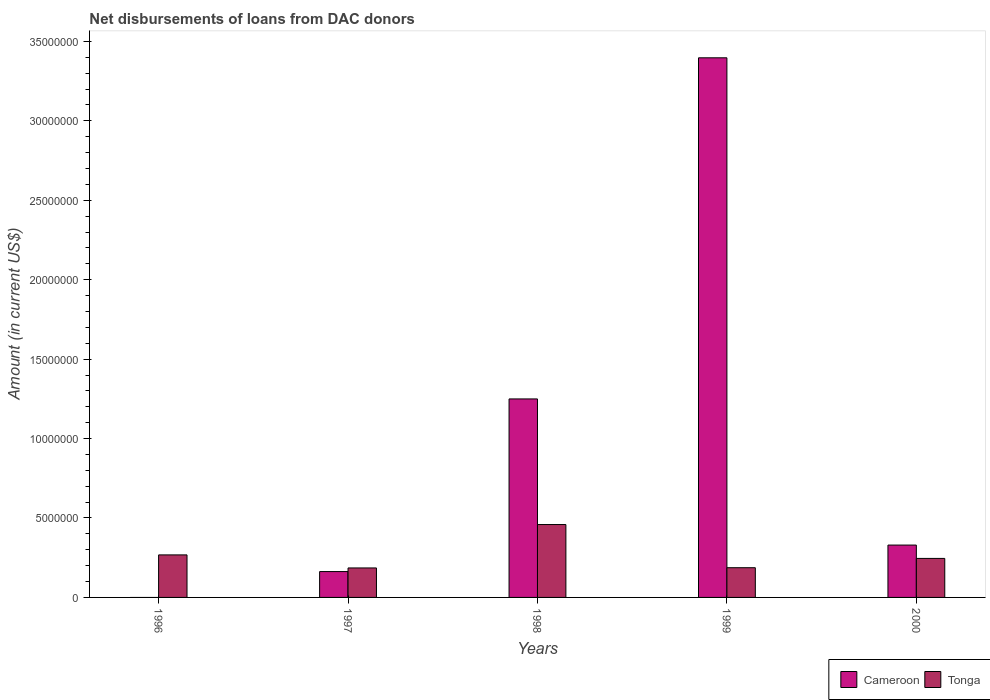How many different coloured bars are there?
Your response must be concise. 2. How many bars are there on the 5th tick from the left?
Offer a terse response. 2. How many bars are there on the 3rd tick from the right?
Your answer should be very brief. 2. What is the amount of loans disbursed in Cameroon in 1998?
Keep it short and to the point. 1.25e+07. Across all years, what is the maximum amount of loans disbursed in Tonga?
Ensure brevity in your answer.  4.59e+06. Across all years, what is the minimum amount of loans disbursed in Cameroon?
Offer a terse response. 0. In which year was the amount of loans disbursed in Tonga maximum?
Give a very brief answer. 1998. What is the total amount of loans disbursed in Tonga in the graph?
Ensure brevity in your answer.  1.34e+07. What is the difference between the amount of loans disbursed in Cameroon in 1999 and that in 2000?
Your answer should be compact. 3.07e+07. What is the difference between the amount of loans disbursed in Tonga in 1997 and the amount of loans disbursed in Cameroon in 1996?
Keep it short and to the point. 1.86e+06. What is the average amount of loans disbursed in Cameroon per year?
Provide a succinct answer. 1.03e+07. In the year 1999, what is the difference between the amount of loans disbursed in Tonga and amount of loans disbursed in Cameroon?
Provide a short and direct response. -3.21e+07. In how many years, is the amount of loans disbursed in Cameroon greater than 28000000 US$?
Provide a succinct answer. 1. What is the ratio of the amount of loans disbursed in Tonga in 1996 to that in 1999?
Provide a short and direct response. 1.43. Is the amount of loans disbursed in Tonga in 1996 less than that in 1998?
Give a very brief answer. Yes. Is the difference between the amount of loans disbursed in Tonga in 1997 and 1999 greater than the difference between the amount of loans disbursed in Cameroon in 1997 and 1999?
Your answer should be compact. Yes. What is the difference between the highest and the second highest amount of loans disbursed in Cameroon?
Your answer should be compact. 2.15e+07. What is the difference between the highest and the lowest amount of loans disbursed in Tonga?
Give a very brief answer. 2.73e+06. How many bars are there?
Offer a very short reply. 9. Are all the bars in the graph horizontal?
Ensure brevity in your answer.  No. What is the difference between two consecutive major ticks on the Y-axis?
Keep it short and to the point. 5.00e+06. How are the legend labels stacked?
Your answer should be compact. Horizontal. What is the title of the graph?
Keep it short and to the point. Net disbursements of loans from DAC donors. Does "Jordan" appear as one of the legend labels in the graph?
Give a very brief answer. No. What is the label or title of the X-axis?
Make the answer very short. Years. What is the label or title of the Y-axis?
Provide a short and direct response. Amount (in current US$). What is the Amount (in current US$) in Cameroon in 1996?
Provide a short and direct response. 0. What is the Amount (in current US$) of Tonga in 1996?
Your response must be concise. 2.68e+06. What is the Amount (in current US$) of Cameroon in 1997?
Offer a terse response. 1.63e+06. What is the Amount (in current US$) in Tonga in 1997?
Offer a very short reply. 1.86e+06. What is the Amount (in current US$) in Cameroon in 1998?
Keep it short and to the point. 1.25e+07. What is the Amount (in current US$) of Tonga in 1998?
Provide a short and direct response. 4.59e+06. What is the Amount (in current US$) in Cameroon in 1999?
Keep it short and to the point. 3.40e+07. What is the Amount (in current US$) of Tonga in 1999?
Offer a very short reply. 1.87e+06. What is the Amount (in current US$) in Cameroon in 2000?
Give a very brief answer. 3.30e+06. What is the Amount (in current US$) of Tonga in 2000?
Your answer should be compact. 2.46e+06. Across all years, what is the maximum Amount (in current US$) in Cameroon?
Your answer should be very brief. 3.40e+07. Across all years, what is the maximum Amount (in current US$) of Tonga?
Give a very brief answer. 4.59e+06. Across all years, what is the minimum Amount (in current US$) in Cameroon?
Make the answer very short. 0. Across all years, what is the minimum Amount (in current US$) of Tonga?
Keep it short and to the point. 1.86e+06. What is the total Amount (in current US$) in Cameroon in the graph?
Ensure brevity in your answer.  5.14e+07. What is the total Amount (in current US$) in Tonga in the graph?
Offer a very short reply. 1.34e+07. What is the difference between the Amount (in current US$) of Tonga in 1996 and that in 1997?
Provide a succinct answer. 8.21e+05. What is the difference between the Amount (in current US$) in Tonga in 1996 and that in 1998?
Your answer should be very brief. -1.91e+06. What is the difference between the Amount (in current US$) in Tonga in 1996 and that in 1999?
Provide a short and direct response. 8.06e+05. What is the difference between the Amount (in current US$) of Tonga in 1996 and that in 2000?
Your response must be concise. 2.21e+05. What is the difference between the Amount (in current US$) in Cameroon in 1997 and that in 1998?
Keep it short and to the point. -1.09e+07. What is the difference between the Amount (in current US$) of Tonga in 1997 and that in 1998?
Your answer should be very brief. -2.73e+06. What is the difference between the Amount (in current US$) in Cameroon in 1997 and that in 1999?
Offer a terse response. -3.23e+07. What is the difference between the Amount (in current US$) of Tonga in 1997 and that in 1999?
Your answer should be compact. -1.50e+04. What is the difference between the Amount (in current US$) of Cameroon in 1997 and that in 2000?
Offer a terse response. -1.67e+06. What is the difference between the Amount (in current US$) in Tonga in 1997 and that in 2000?
Provide a short and direct response. -6.00e+05. What is the difference between the Amount (in current US$) in Cameroon in 1998 and that in 1999?
Offer a very short reply. -2.15e+07. What is the difference between the Amount (in current US$) of Tonga in 1998 and that in 1999?
Your answer should be very brief. 2.72e+06. What is the difference between the Amount (in current US$) of Cameroon in 1998 and that in 2000?
Your answer should be very brief. 9.20e+06. What is the difference between the Amount (in current US$) in Tonga in 1998 and that in 2000?
Give a very brief answer. 2.13e+06. What is the difference between the Amount (in current US$) in Cameroon in 1999 and that in 2000?
Your answer should be very brief. 3.07e+07. What is the difference between the Amount (in current US$) of Tonga in 1999 and that in 2000?
Keep it short and to the point. -5.85e+05. What is the difference between the Amount (in current US$) in Cameroon in 1997 and the Amount (in current US$) in Tonga in 1998?
Offer a terse response. -2.96e+06. What is the difference between the Amount (in current US$) of Cameroon in 1997 and the Amount (in current US$) of Tonga in 1999?
Keep it short and to the point. -2.43e+05. What is the difference between the Amount (in current US$) in Cameroon in 1997 and the Amount (in current US$) in Tonga in 2000?
Offer a very short reply. -8.28e+05. What is the difference between the Amount (in current US$) of Cameroon in 1998 and the Amount (in current US$) of Tonga in 1999?
Provide a succinct answer. 1.06e+07. What is the difference between the Amount (in current US$) in Cameroon in 1998 and the Amount (in current US$) in Tonga in 2000?
Offer a terse response. 1.00e+07. What is the difference between the Amount (in current US$) in Cameroon in 1999 and the Amount (in current US$) in Tonga in 2000?
Ensure brevity in your answer.  3.15e+07. What is the average Amount (in current US$) of Cameroon per year?
Provide a succinct answer. 1.03e+07. What is the average Amount (in current US$) in Tonga per year?
Your answer should be compact. 2.69e+06. In the year 1997, what is the difference between the Amount (in current US$) in Cameroon and Amount (in current US$) in Tonga?
Keep it short and to the point. -2.28e+05. In the year 1998, what is the difference between the Amount (in current US$) in Cameroon and Amount (in current US$) in Tonga?
Ensure brevity in your answer.  7.91e+06. In the year 1999, what is the difference between the Amount (in current US$) of Cameroon and Amount (in current US$) of Tonga?
Ensure brevity in your answer.  3.21e+07. In the year 2000, what is the difference between the Amount (in current US$) in Cameroon and Amount (in current US$) in Tonga?
Keep it short and to the point. 8.40e+05. What is the ratio of the Amount (in current US$) of Tonga in 1996 to that in 1997?
Your answer should be very brief. 1.44. What is the ratio of the Amount (in current US$) in Tonga in 1996 to that in 1998?
Offer a terse response. 0.58. What is the ratio of the Amount (in current US$) in Tonga in 1996 to that in 1999?
Ensure brevity in your answer.  1.43. What is the ratio of the Amount (in current US$) in Tonga in 1996 to that in 2000?
Offer a very short reply. 1.09. What is the ratio of the Amount (in current US$) in Cameroon in 1997 to that in 1998?
Offer a very short reply. 0.13. What is the ratio of the Amount (in current US$) in Tonga in 1997 to that in 1998?
Ensure brevity in your answer.  0.4. What is the ratio of the Amount (in current US$) of Cameroon in 1997 to that in 1999?
Ensure brevity in your answer.  0.05. What is the ratio of the Amount (in current US$) of Cameroon in 1997 to that in 2000?
Your response must be concise. 0.49. What is the ratio of the Amount (in current US$) of Tonga in 1997 to that in 2000?
Keep it short and to the point. 0.76. What is the ratio of the Amount (in current US$) in Cameroon in 1998 to that in 1999?
Provide a short and direct response. 0.37. What is the ratio of the Amount (in current US$) of Tonga in 1998 to that in 1999?
Make the answer very short. 2.45. What is the ratio of the Amount (in current US$) of Cameroon in 1998 to that in 2000?
Make the answer very short. 3.79. What is the ratio of the Amount (in current US$) in Tonga in 1998 to that in 2000?
Provide a short and direct response. 1.87. What is the ratio of the Amount (in current US$) in Cameroon in 1999 to that in 2000?
Provide a succinct answer. 10.31. What is the ratio of the Amount (in current US$) of Tonga in 1999 to that in 2000?
Your answer should be very brief. 0.76. What is the difference between the highest and the second highest Amount (in current US$) of Cameroon?
Your response must be concise. 2.15e+07. What is the difference between the highest and the second highest Amount (in current US$) in Tonga?
Your answer should be very brief. 1.91e+06. What is the difference between the highest and the lowest Amount (in current US$) in Cameroon?
Your answer should be compact. 3.40e+07. What is the difference between the highest and the lowest Amount (in current US$) of Tonga?
Your answer should be compact. 2.73e+06. 